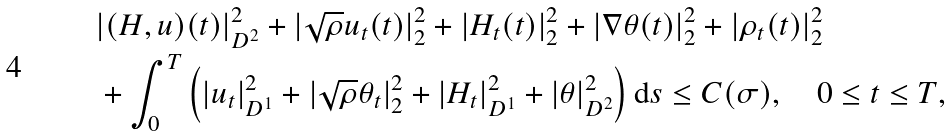Convert formula to latex. <formula><loc_0><loc_0><loc_500><loc_500>& | ( H , u ) ( t ) | ^ { 2 } _ { D ^ { 2 } } + | \sqrt { \rho } u _ { t } ( t ) | ^ { 2 } _ { 2 } + | H _ { t } ( t ) | ^ { 2 } _ { 2 } + | \nabla \theta ( t ) | ^ { 2 } _ { 2 } + | \rho _ { t } ( t ) | ^ { 2 } _ { 2 } \\ & + \int _ { 0 } ^ { T } \left ( | u _ { t } | ^ { 2 } _ { D ^ { 1 } } + | \sqrt { \rho } \theta _ { t } | ^ { 2 } _ { 2 } + | H _ { t } | ^ { 2 } _ { D ^ { 1 } } + | \theta | ^ { 2 } _ { D ^ { 2 } } \right ) \text {d} s \leq C ( \sigma ) , \quad 0 \leq t \leq T ,</formula> 